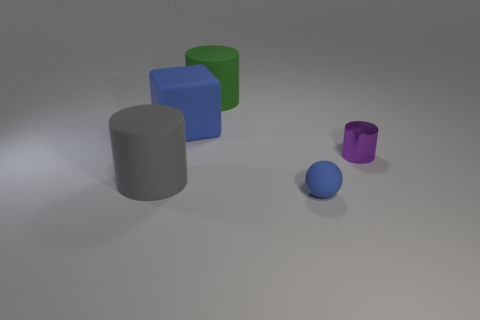There is a big thing in front of the large blue matte object; what is its material?
Your response must be concise. Rubber. Do the big rubber object that is in front of the small shiny object and the green object have the same shape?
Offer a very short reply. Yes. Does the purple cylinder have the same material as the green thing?
Give a very brief answer. No. There is a matte block that is the same color as the rubber sphere; what size is it?
Give a very brief answer. Large. What size is the sphere that is made of the same material as the big gray cylinder?
Your answer should be very brief. Small. What shape is the tiny object in front of the small object behind the big cylinder in front of the shiny thing?
Give a very brief answer. Sphere. What is the size of the gray thing that is the same shape as the green thing?
Provide a succinct answer. Large. There is a cylinder that is to the left of the small metal cylinder and behind the big gray rubber thing; how big is it?
Provide a succinct answer. Large. What shape is the tiny rubber thing that is the same color as the cube?
Keep it short and to the point. Sphere. What is the size of the blue matte object that is left of the blue matte ball?
Make the answer very short. Large. 